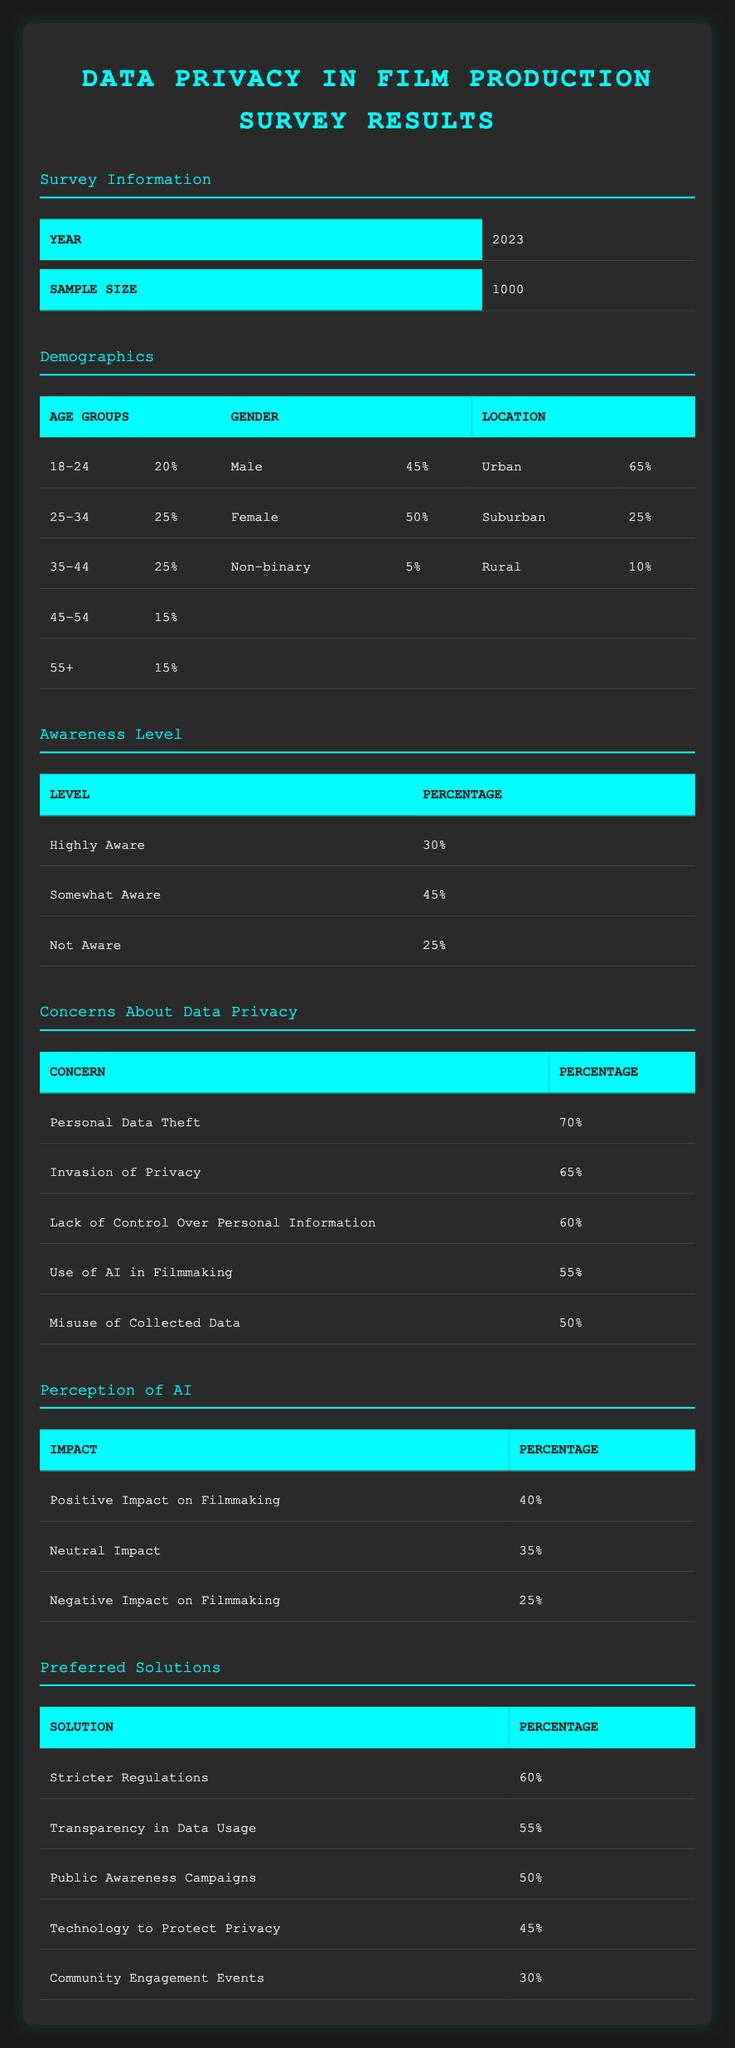What percentage of respondents identify as Non-binary? The table under the "Gender" demographics section shows that Non-binary respondents account for 5% of the total sample.
Answer: 5% What is the total percentage of respondents who are somewhat aware or highly aware of data privacy issues? To find this total, we sum the percentages of "Highly Aware" (30%) and "Somewhat Aware" (45%), which equals 30 + 45 = 75%.
Answer: 75% Is there a greater percentage of males or females among the respondents? The table indicates that 45% of respondents are male while 50% are female, thus female respondents make up a larger percentage.
Answer: Yes What is the percentage of respondents who expressed concerns about the misuse of collected data? From the "Concerns About Data Privacy" section, it is noted that 50% of respondents expressed concern regarding the misuse of collected data.
Answer: 50% What percentage of respondents live in suburban areas and have concerns about personal data theft? The "Location" section shows 25% of respondents live in suburban areas and the "Concerns About Data Privacy" indicates that 70% are concerned about personal data theft. These are independent figures and do not directly relate to each other in this context, but we can state the percentage of each separately.
Answer: 25% suburban, 70% personal data theft Which preferred solution received the lowest percentage of support among respondents? The table in the "Preferred Solutions" section lists various solutions with their percentages, and the lowest listed is "Community Engagement Events" at 30%.
Answer: 30% If we combine the percentages of respondents who have concerns about personal data theft and invasion of privacy, what is the total percentage? To find this total, we add the percentages for both concerns: "Personal Data Theft" at 70% and "Invasion of Privacy" at 65%, resulting in a combined total of 70 + 65 = 135%.
Answer: 135% What proportion of the surveyed individuals believe AI has a positive impact on filmmaking? According to the "Perception of AI" section, 40% of respondents believe that AI has a positive impact on filmmaking.
Answer: 40% How many more respondents are in the 25-34 age group compared to the 45-54 age group? The count for the 25-34 age group is 25% while that for the 45-54 age group is 15%. The difference is calculated as 25% - 15% = 10%.
Answer: 10% 